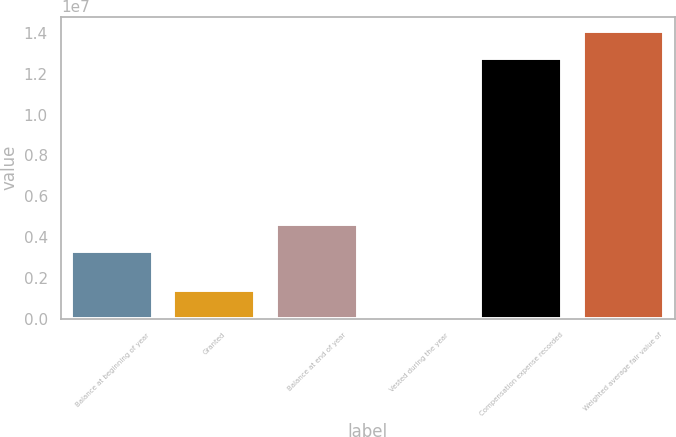Convert chart. <chart><loc_0><loc_0><loc_500><loc_500><bar_chart><fcel>Balance at beginning of year<fcel>Granted<fcel>Balance at end of year<fcel>Vested during the year<fcel>Compensation expense recorded<fcel>Weighted average fair value of<nl><fcel>3.29822e+06<fcel>1.42695e+06<fcel>4.63305e+06<fcel>92114<fcel>1.27577e+07<fcel>1.40925e+07<nl></chart> 